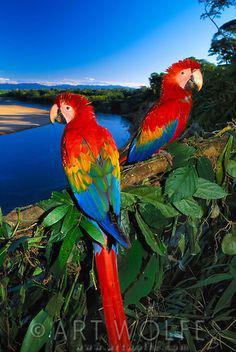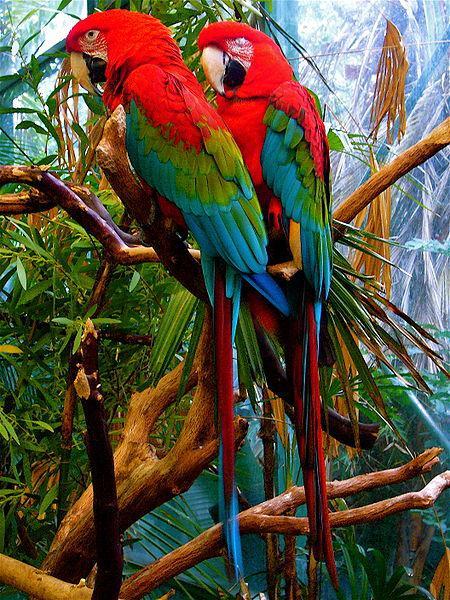The first image is the image on the left, the second image is the image on the right. Assess this claim about the two images: "There are exactly two birds in the image on the right.". Correct or not? Answer yes or no. Yes. The first image is the image on the left, the second image is the image on the right. Evaluate the accuracy of this statement regarding the images: "There are exactly two birds in the image on the right.". Is it true? Answer yes or no. Yes. The first image is the image on the left, the second image is the image on the right. Analyze the images presented: Is the assertion "In one image, two parrots are sitting together, but facing different directions." valid? Answer yes or no. Yes. The first image is the image on the left, the second image is the image on the right. Analyze the images presented: Is the assertion "There are only two birds and neither of them is flying." valid? Answer yes or no. No. 